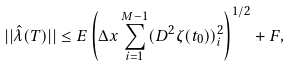Convert formula to latex. <formula><loc_0><loc_0><loc_500><loc_500>| | \hat { \lambda } ( T ) | | \leq E \left ( \Delta x \sum _ { i = 1 } ^ { M - 1 } ( D ^ { 2 } \zeta ( t _ { 0 } ) ) _ { i } ^ { 2 } \right ) ^ { 1 / 2 } + F ,</formula> 